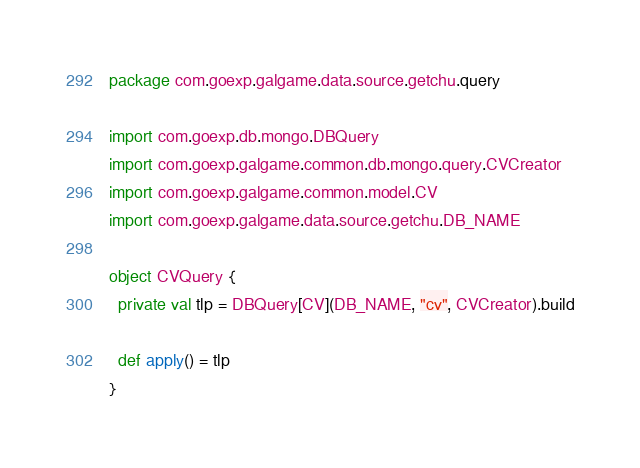<code> <loc_0><loc_0><loc_500><loc_500><_Scala_>package com.goexp.galgame.data.source.getchu.query

import com.goexp.db.mongo.DBQuery
import com.goexp.galgame.common.db.mongo.query.CVCreator
import com.goexp.galgame.common.model.CV
import com.goexp.galgame.data.source.getchu.DB_NAME

object CVQuery {
  private val tlp = DBQuery[CV](DB_NAME, "cv", CVCreator).build

  def apply() = tlp
}</code> 